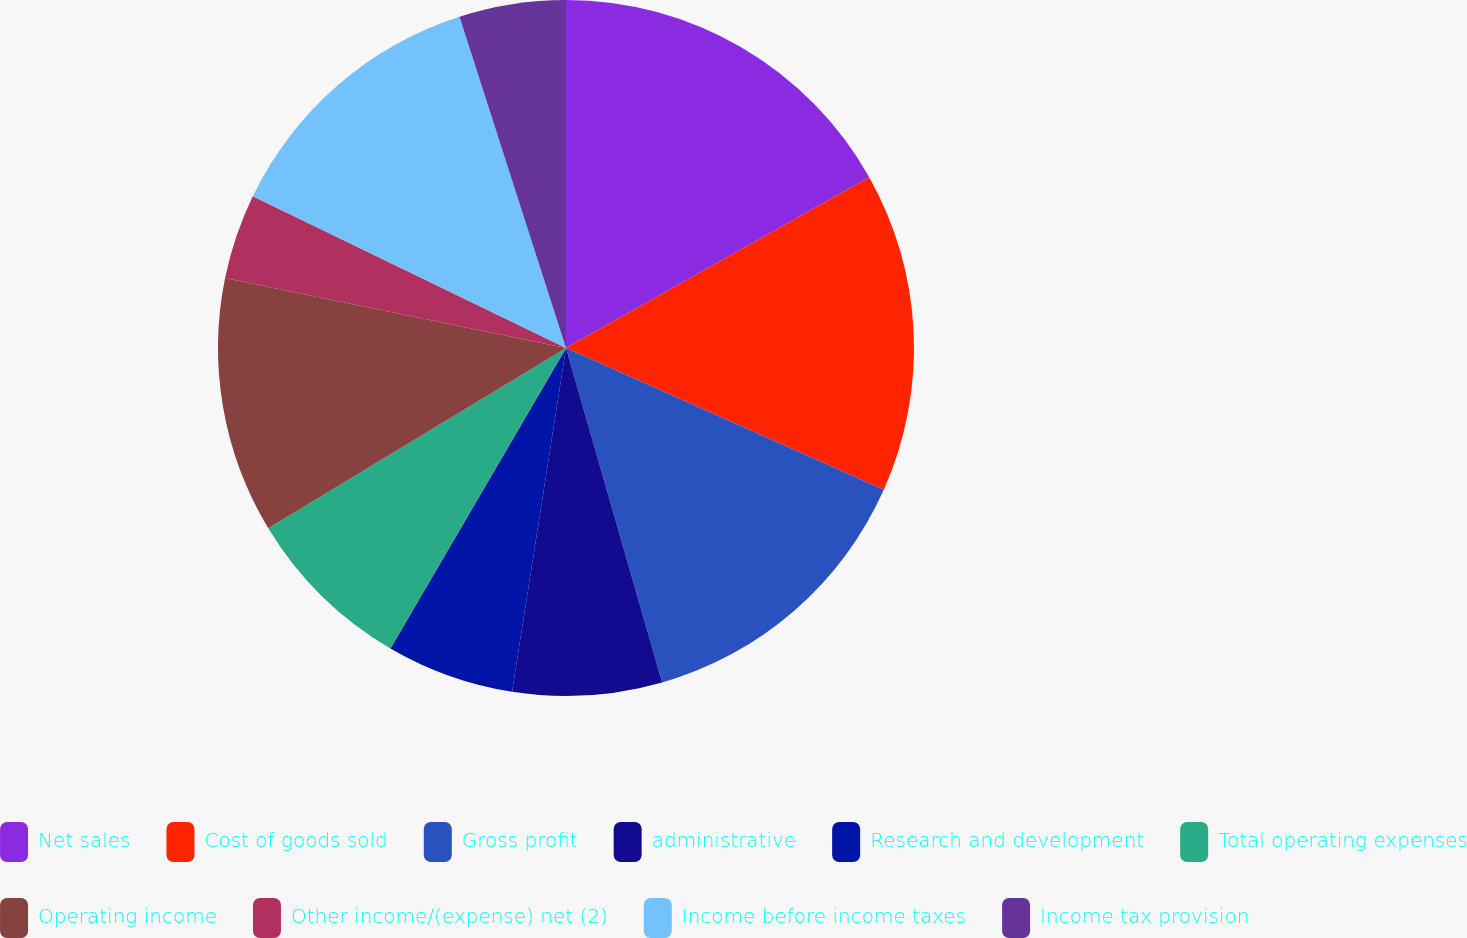Convert chart to OTSL. <chart><loc_0><loc_0><loc_500><loc_500><pie_chart><fcel>Net sales<fcel>Cost of goods sold<fcel>Gross profit<fcel>administrative<fcel>Research and development<fcel>Total operating expenses<fcel>Operating income<fcel>Other income/(expense) net (2)<fcel>Income before income taxes<fcel>Income tax provision<nl><fcel>16.83%<fcel>14.85%<fcel>13.86%<fcel>6.93%<fcel>5.94%<fcel>7.92%<fcel>11.88%<fcel>3.96%<fcel>12.87%<fcel>4.95%<nl></chart> 